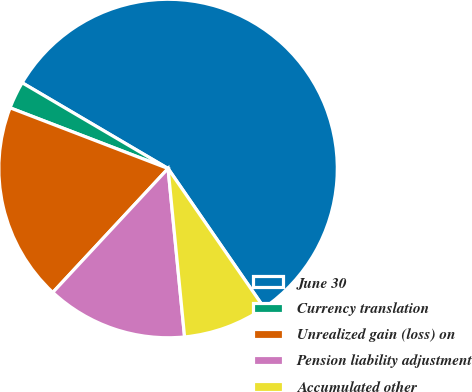Convert chart to OTSL. <chart><loc_0><loc_0><loc_500><loc_500><pie_chart><fcel>June 30<fcel>Currency translation<fcel>Unrealized gain (loss) on<fcel>Pension liability adjustment<fcel>Accumulated other<nl><fcel>56.93%<fcel>2.62%<fcel>18.91%<fcel>13.48%<fcel>8.05%<nl></chart> 